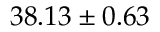<formula> <loc_0><loc_0><loc_500><loc_500>3 8 . 1 3 \pm 0 . 6 3</formula> 